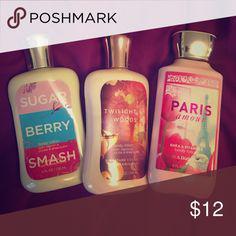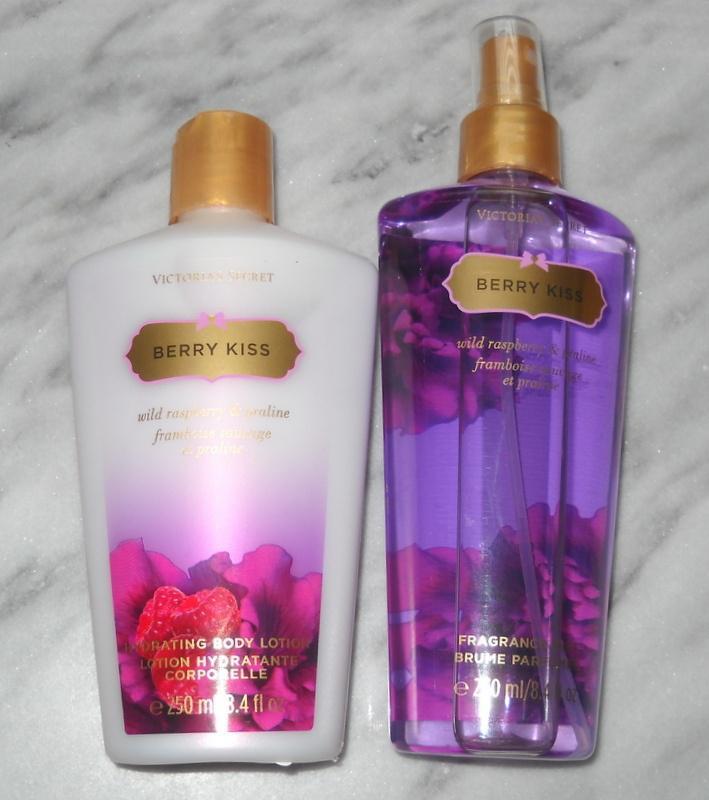The first image is the image on the left, the second image is the image on the right. Considering the images on both sides, is "There are five lotions/fragrances in total." valid? Answer yes or no. Yes. 